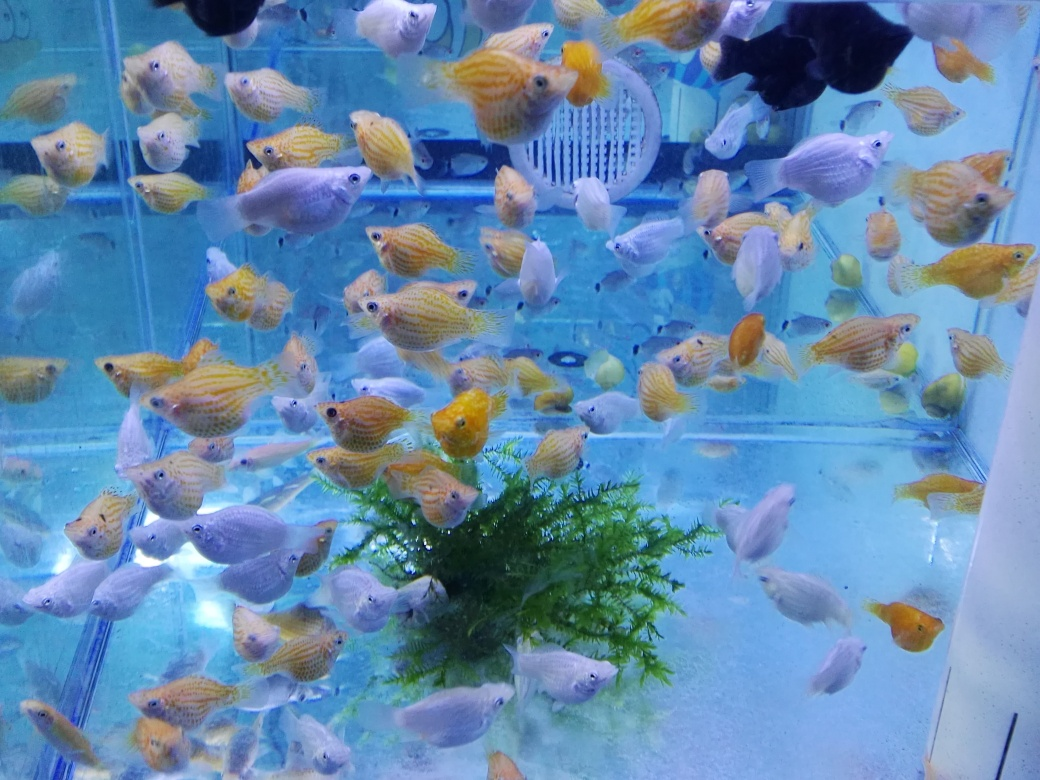Are there any signs of overcrowding in this fish tank? While the tank seems populous, there doesn't appear to be immediate signs of overcrowding such as aggressive behavior or fish gasping for air at the surface. However, long-term health can be impacted if the population density is too high, so it's important to monitor the fish and maintain appropriate stocking levels for the size of the tank. 